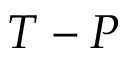<formula> <loc_0><loc_0><loc_500><loc_500>T - P</formula> 